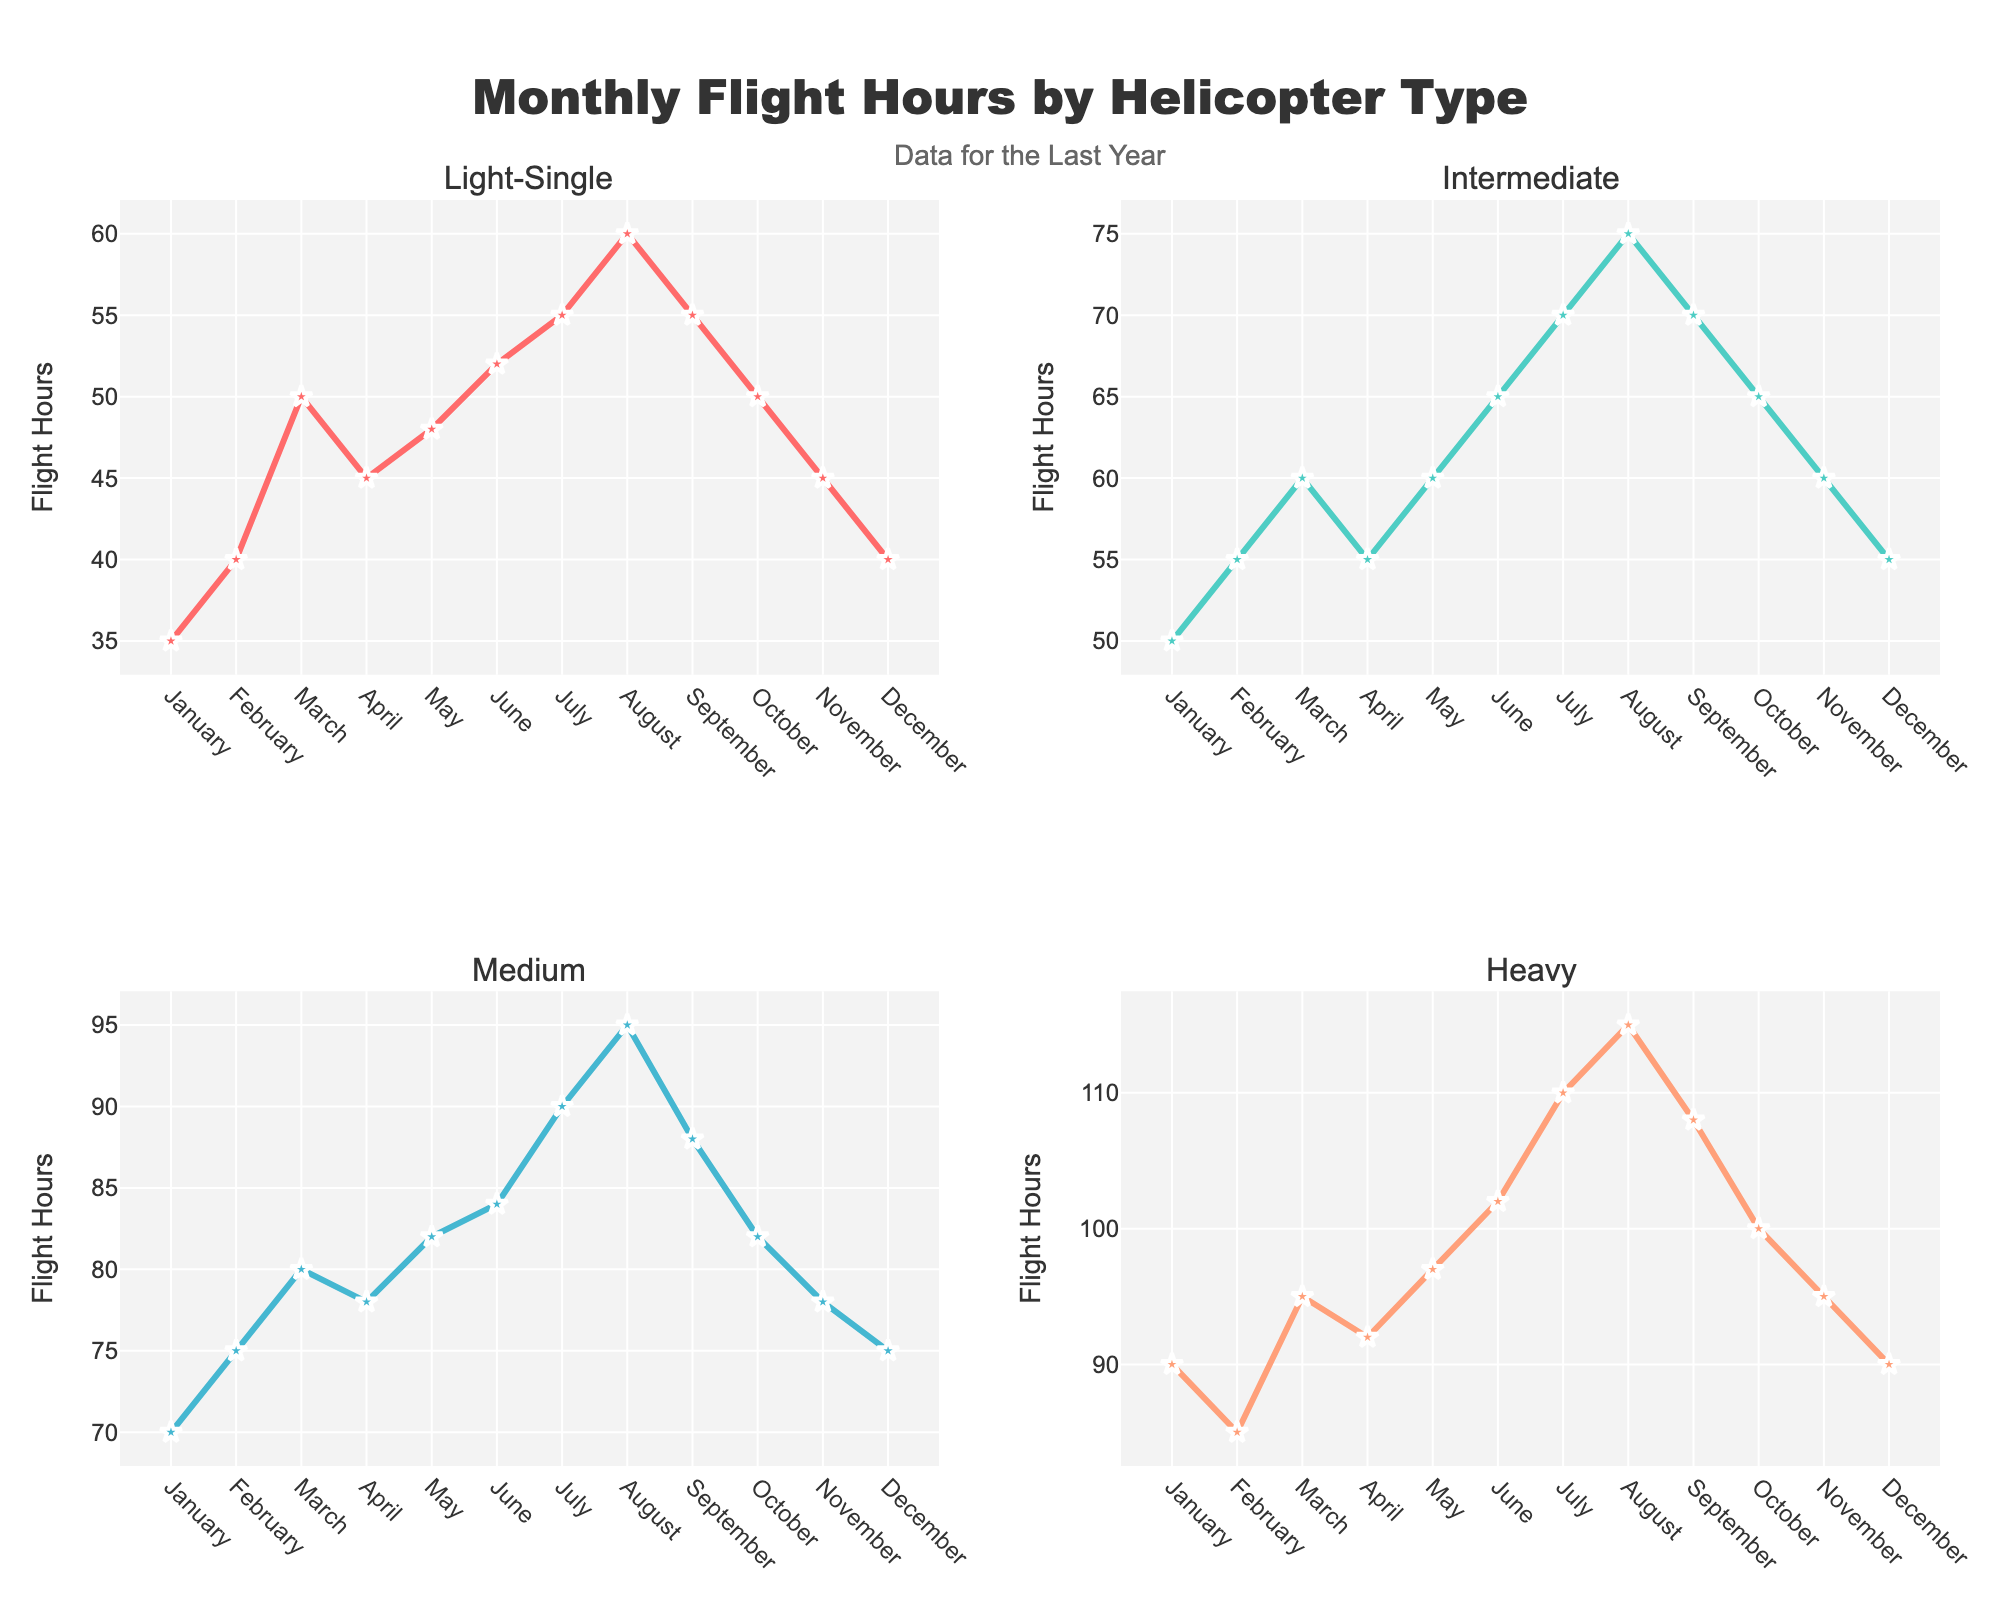What is the title of the figure? The title of the figure is located at the top center, and it reads "Monthly Flight Hours by Helicopter Type".
Answer: Monthly Flight Hours by Helicopter Type How many helicopter types are shown in the figure? The figure consists of four subplots, each labeled with a different helicopter type. The types are Light-Single, Intermediate, Medium, and Heavy.
Answer: 4 What is the trend in flight hours for Light-Single helicopters from January to December? By observing the plot in the Light-Single subplot, we can see that flight hours generally increase from January to August and then decrease towards December.
Answer: Increase then Decrease Which month had the highest flight hours for Heavy helicopters? In the Heavy subplot, the point with the highest flight hour is the peak of the series. This occurs in August with 115 flight hours.
Answer: August During which month did the flight hours for Intermediate helicopters match those of Medium helicopters? By comparing the subplots for Intermediate and Medium helicopters, we find that April is the month where both have close flight hours around 55 (Intermediate) and 78 (Medium), which are not exactly the same but relatively close.
Answer: April What is the difference in flight hours for Heavy helicopters between the highest and lowest months? The highest flight hours for Heavy helicopters is in August with 115 hours, and the lowest is in February and December with 90 hours. The difference is 115 - 90 = 25 hours.
Answer: 25 hours How does October’s flight hours for Light-Single helicopters compare to that of Heavy helicopters? In October, the flight hours for Light-Single helicopters are 50, while for Heavy helicopters, it is 100. The Heavy helicopters have 50 more flight hours than Light-Single.
Answer: Heavy helicopters have 50 more hours What is the average flight hours for Medium helicopters over the entire year? The flight hours for Medium helicopters are 70, 75, 80, 78, 82, 84, 90, 95, 88, 82, 78, 75. Summing these values gives 977, and dividing by 12 months yields an average of 81.42.
Answer: 81.42 What is the total flight hours for Intermediate helicopters from January to June? Summing up the flight hours from January to June for Intermediate helicopters: 50 + 55 + 60 + 55 + 60 + 65 = 345.
Answer: 345 